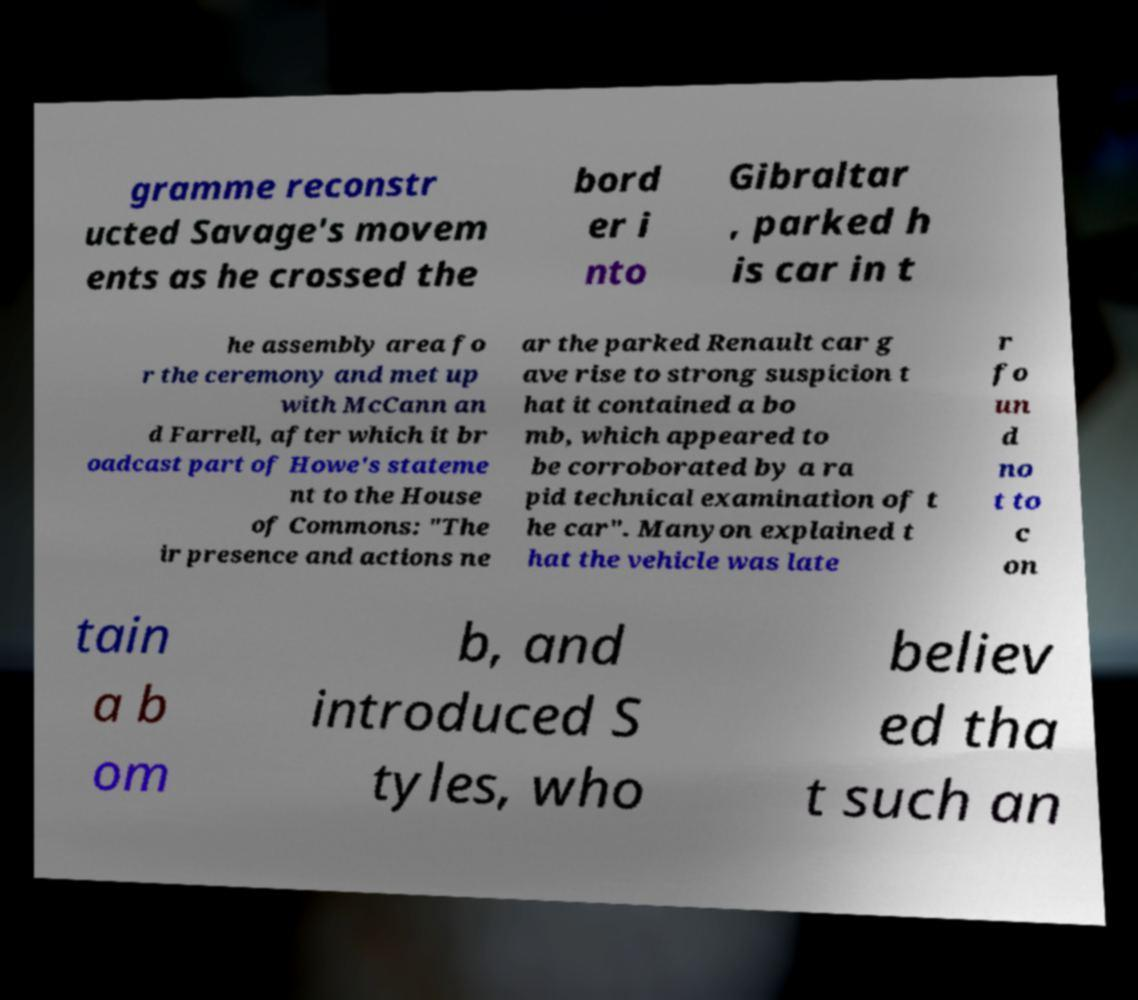Can you accurately transcribe the text from the provided image for me? gramme reconstr ucted Savage's movem ents as he crossed the bord er i nto Gibraltar , parked h is car in t he assembly area fo r the ceremony and met up with McCann an d Farrell, after which it br oadcast part of Howe's stateme nt to the House of Commons: "The ir presence and actions ne ar the parked Renault car g ave rise to strong suspicion t hat it contained a bo mb, which appeared to be corroborated by a ra pid technical examination of t he car". Manyon explained t hat the vehicle was late r fo un d no t to c on tain a b om b, and introduced S tyles, who believ ed tha t such an 